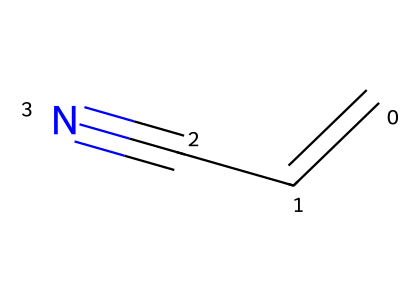How many carbon atoms are present in acrylonitrile? The SMILES representation "C=CC#N" indicates a total of three carbon atoms, as represented by the three 'C' characters in the sequence.
Answer: three What functional group is present in acrylonitrile? The presence of the "C#N" portion of the SMILES indicates a cyano group, which characterizes acrylonitrile as a nitrile compound.
Answer: cyano group How many double bonds are in the structure of acrylonitrile? The "C=C" portion in the SMILES denotes one double bond between the first two carbon atoms, indicating only one double bond within the entire structure.
Answer: one What is the degree of unsaturation in acrylonitrile? The molecule has one double bond and one triple bond (from the cyano group), contributing to a total of two degrees of unsaturation. Unsaturation is calculated as (number of rings + number of double bonds) + (number of triple bonds), so here it is 0 + 1 + 1 = 2.
Answer: two What is the total number of nitrogen atoms in acrylonitrile? The presence of "N" in the SMILES indicates there is one nitrogen atom in the structure of acrylonitrile as shown in "C#N".
Answer: one Does acrylonitrile contain a ring structure? The SMILES representation does not contain any indication of a ring structure (such as numbers denoting atom connections), so we can conclude that there are no rings in the composition of acrylonitrile.
Answer: no 